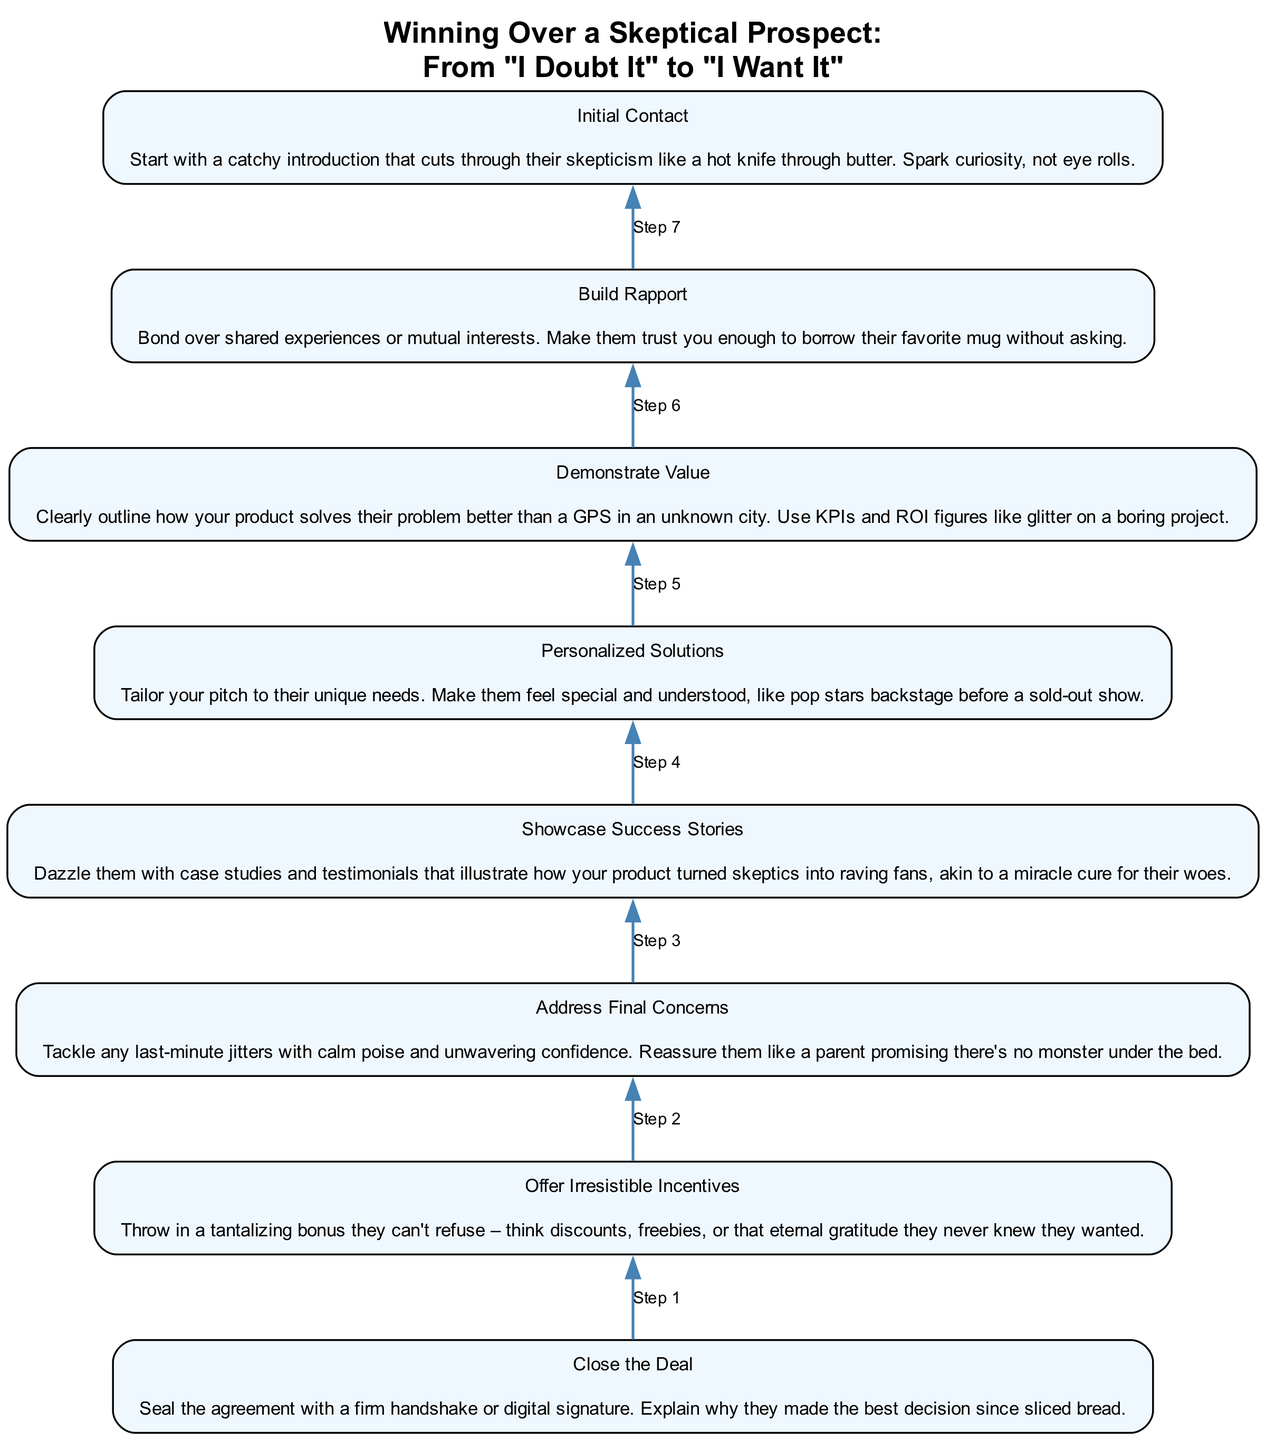What is the final step in the process? The final step, as indicated by the bottom node of the flow chart, is "Close the Deal." This means it's the last action taken to finalize a sale.
Answer: Close the Deal How many steps are there in total? The diagram lists a total of eight steps, starting from "Initial Contact" to "Close the Deal." Each step progresses logically to the final action.
Answer: Eight What incentives are offered in the penultimate step? In the step before the final one, "Offer Irresistible Incentives," the description mentions offering enticing bonuses like discounts or freebies. Thus, these incentives aim to persuade the prospect.
Answer: Discounts, freebies Which step occurs immediately after "Demonstrate Value"? "Build Rapport" is the step that occurs right after "Demonstrate Value" in the sequential flow. This indicates a progression from showcasing product value to establishing trust.
Answer: Build Rapport What does the initial contact aim to achieve? The purpose of "Initial Contact" is to spark curiosity and break through skepticism, making a memorable introduction that captures attention effectively.
Answer: Spark curiosity How does "Address Final Concerns" connect to "Showcase Success Stories"? After "Showcase Success Stories," which builds confidence through testimonials, "Address Final Concerns" provides reassurance, responding to any hesitations before closing the deal. This connection shows a logical flow from building confidence to resolving doubts.
Answer: Provides reassurance What feeling should "Personalized Solutions" evoke in the prospect? The aim of "Personalized Solutions" is to make the prospect feel special and understood, akin to the feeling a fan has when meeting their favorite pop star. This emotional connection is essential for successful sales.
Answer: Special and understood What type of experience should be shared in the "Build Rapport" step? Shared experiences or mutual interests are crucial in the "Build Rapport" step, as they enhance trust and connection with the prospect, akin to how friends bond over commonalities.
Answer: Shared experiences 